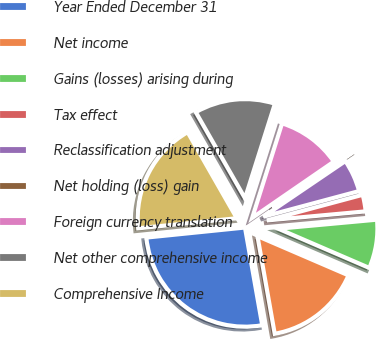Convert chart to OTSL. <chart><loc_0><loc_0><loc_500><loc_500><pie_chart><fcel>Year Ended December 31<fcel>Net income<fcel>Gains (losses) arising during<fcel>Tax effect<fcel>Reclassification adjustment<fcel>Net holding (loss) gain<fcel>Foreign currency translation<fcel>Net other comprehensive income<fcel>Comprehensive Income<nl><fcel>26.17%<fcel>15.74%<fcel>7.93%<fcel>2.71%<fcel>5.32%<fcel>0.11%<fcel>10.53%<fcel>13.14%<fcel>18.35%<nl></chart> 